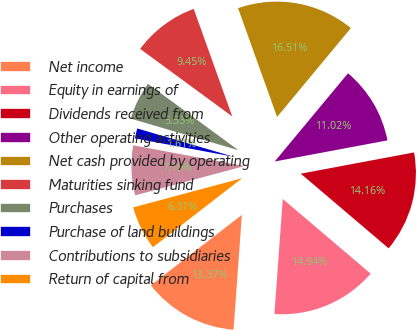<chart> <loc_0><loc_0><loc_500><loc_500><pie_chart><fcel>Net income<fcel>Equity in earnings of<fcel>Dividends received from<fcel>Other operating activities<fcel>Net cash provided by operating<fcel>Maturities sinking fund<fcel>Purchases<fcel>Purchase of land buildings<fcel>Contributions to subsidiaries<fcel>Return of capital from<nl><fcel>13.37%<fcel>14.94%<fcel>14.16%<fcel>11.02%<fcel>16.51%<fcel>9.45%<fcel>5.53%<fcel>1.61%<fcel>7.1%<fcel>6.31%<nl></chart> 